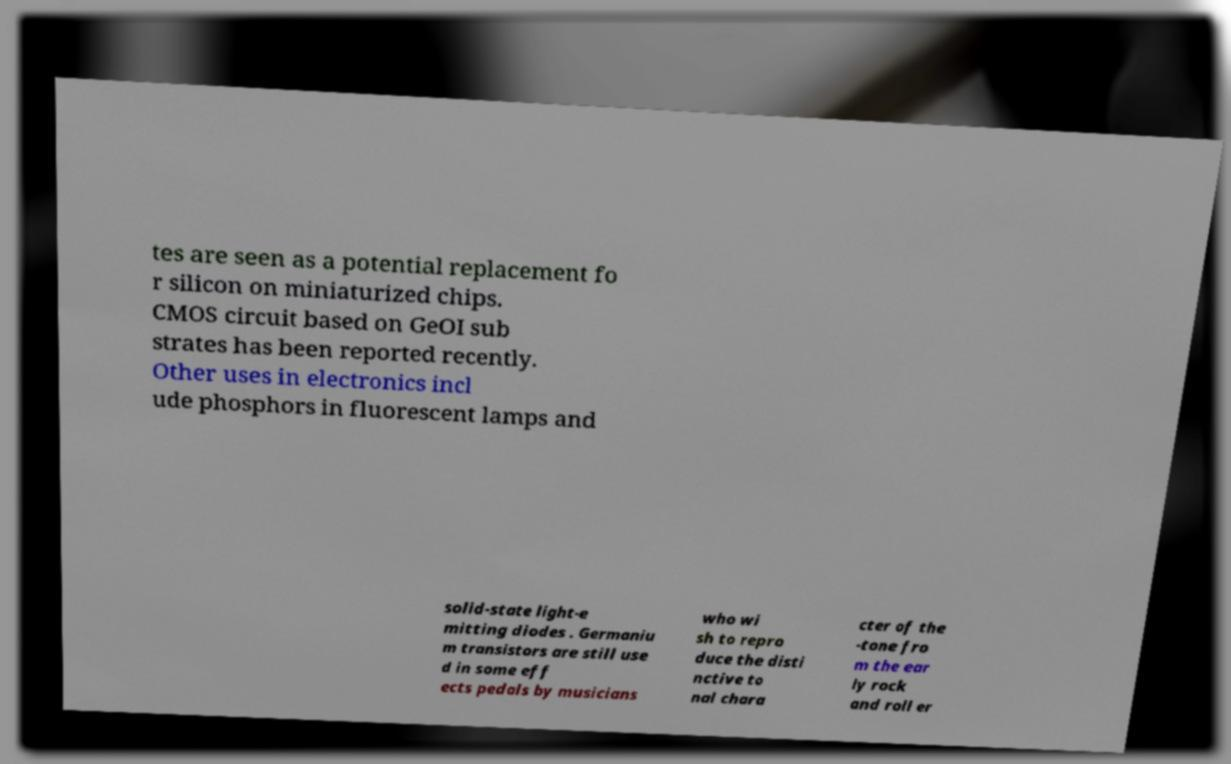Please read and relay the text visible in this image. What does it say? tes are seen as a potential replacement fo r silicon on miniaturized chips. CMOS circuit based on GeOI sub strates has been reported recently. Other uses in electronics incl ude phosphors in fluorescent lamps and solid-state light-e mitting diodes . Germaniu m transistors are still use d in some eff ects pedals by musicians who wi sh to repro duce the disti nctive to nal chara cter of the -tone fro m the ear ly rock and roll er 